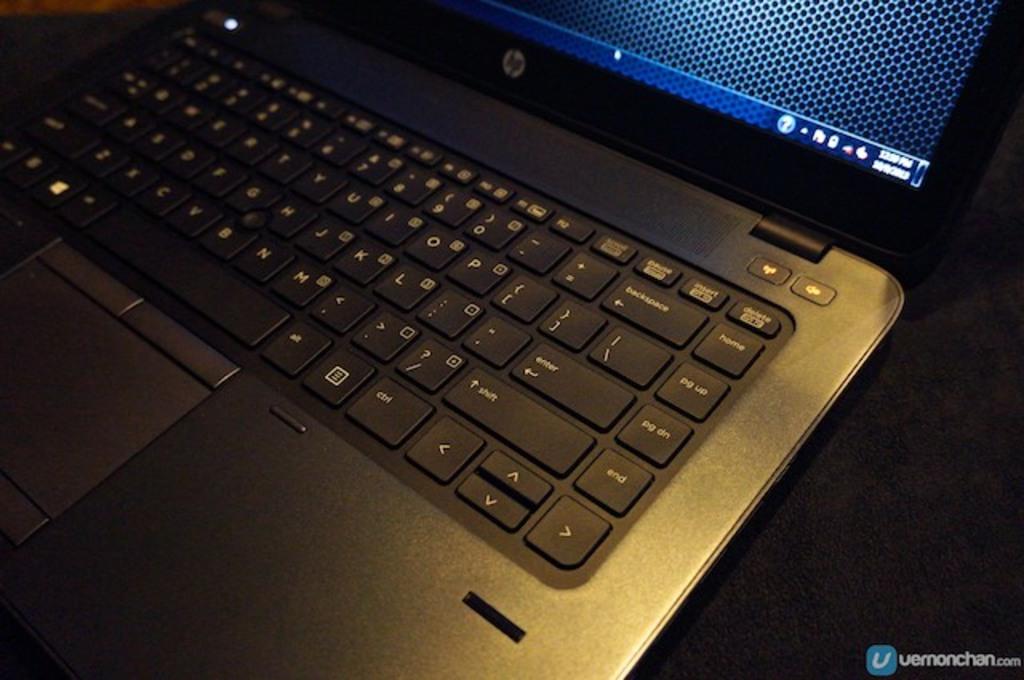What key is above the "l" key?
Provide a succinct answer. 8. What key can be seen to the very top right?
Provide a succinct answer. Delete. 